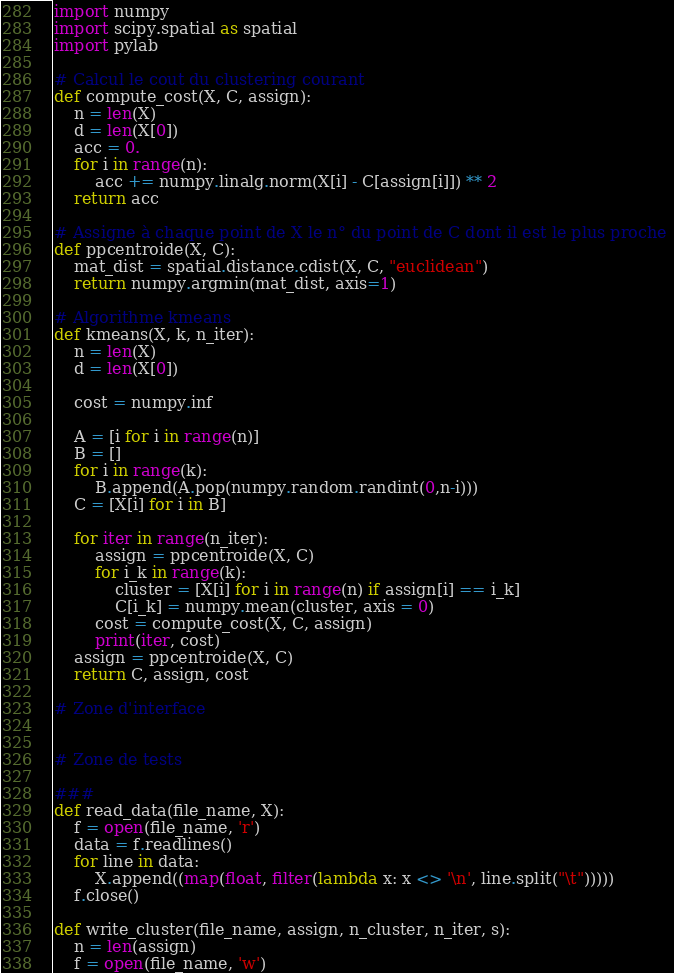<code> <loc_0><loc_0><loc_500><loc_500><_Python_>import numpy
import scipy.spatial as spatial
import pylab

# Calcul le cout du clustering courant
def compute_cost(X, C, assign):
    n = len(X)
    d = len(X[0])
    acc = 0.
    for i in range(n):
        acc += numpy.linalg.norm(X[i] - C[assign[i]]) ** 2
    return acc

# Assigne à chaque point de X le n° du point de C dont il est le plus proche 
def ppcentroide(X, C):
    mat_dist = spatial.distance.cdist(X, C, "euclidean")
    return numpy.argmin(mat_dist, axis=1)

# Algorithme kmeans
def kmeans(X, k, n_iter):
    n = len(X)
    d = len(X[0])
    
    cost = numpy.inf
    
    A = [i for i in range(n)]
    B = []
    for i in range(k):
        B.append(A.pop(numpy.random.randint(0,n-i)))
    C = [X[i] for i in B]

    for iter in range(n_iter):
        assign = ppcentroide(X, C)
        for i_k in range(k):
            cluster = [X[i] for i in range(n) if assign[i] == i_k]
            C[i_k] = numpy.mean(cluster, axis = 0)
        cost = compute_cost(X, C, assign)
        print(iter, cost)
    assign = ppcentroide(X, C)
    return C, assign, cost

# Zone d'interface


# Zone de tests

###
def read_data(file_name, X):
    f = open(file_name, 'r')
    data = f.readlines()
    for line in data:
        X.append((map(float, filter(lambda x: x <> '\n', line.split("\t")))))
    f.close()

def write_cluster(file_name, assign, n_cluster, n_iter, s):
    n = len(assign)
    f = open(file_name, 'w')</code> 